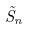Convert formula to latex. <formula><loc_0><loc_0><loc_500><loc_500>\tilde { S } _ { n }</formula> 